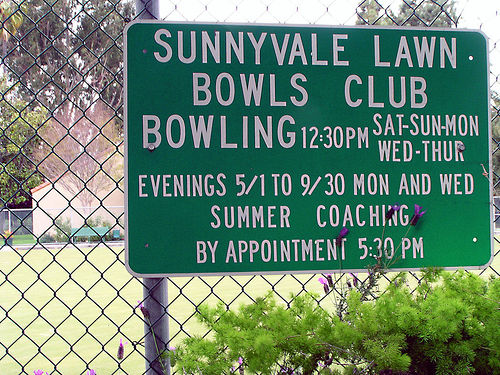<image>
Is there a sign in front of the fence? Yes. The sign is positioned in front of the fence, appearing closer to the camera viewpoint. 